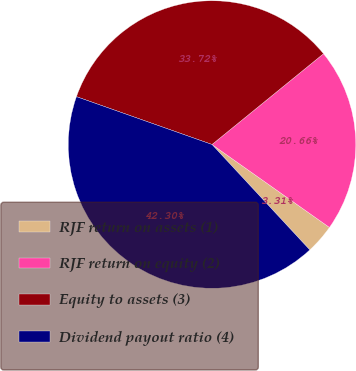Convert chart to OTSL. <chart><loc_0><loc_0><loc_500><loc_500><pie_chart><fcel>RJF return on assets (1)<fcel>RJF return on equity (2)<fcel>Equity to assets (3)<fcel>Dividend payout ratio (4)<nl><fcel>3.31%<fcel>20.66%<fcel>33.72%<fcel>42.3%<nl></chart> 